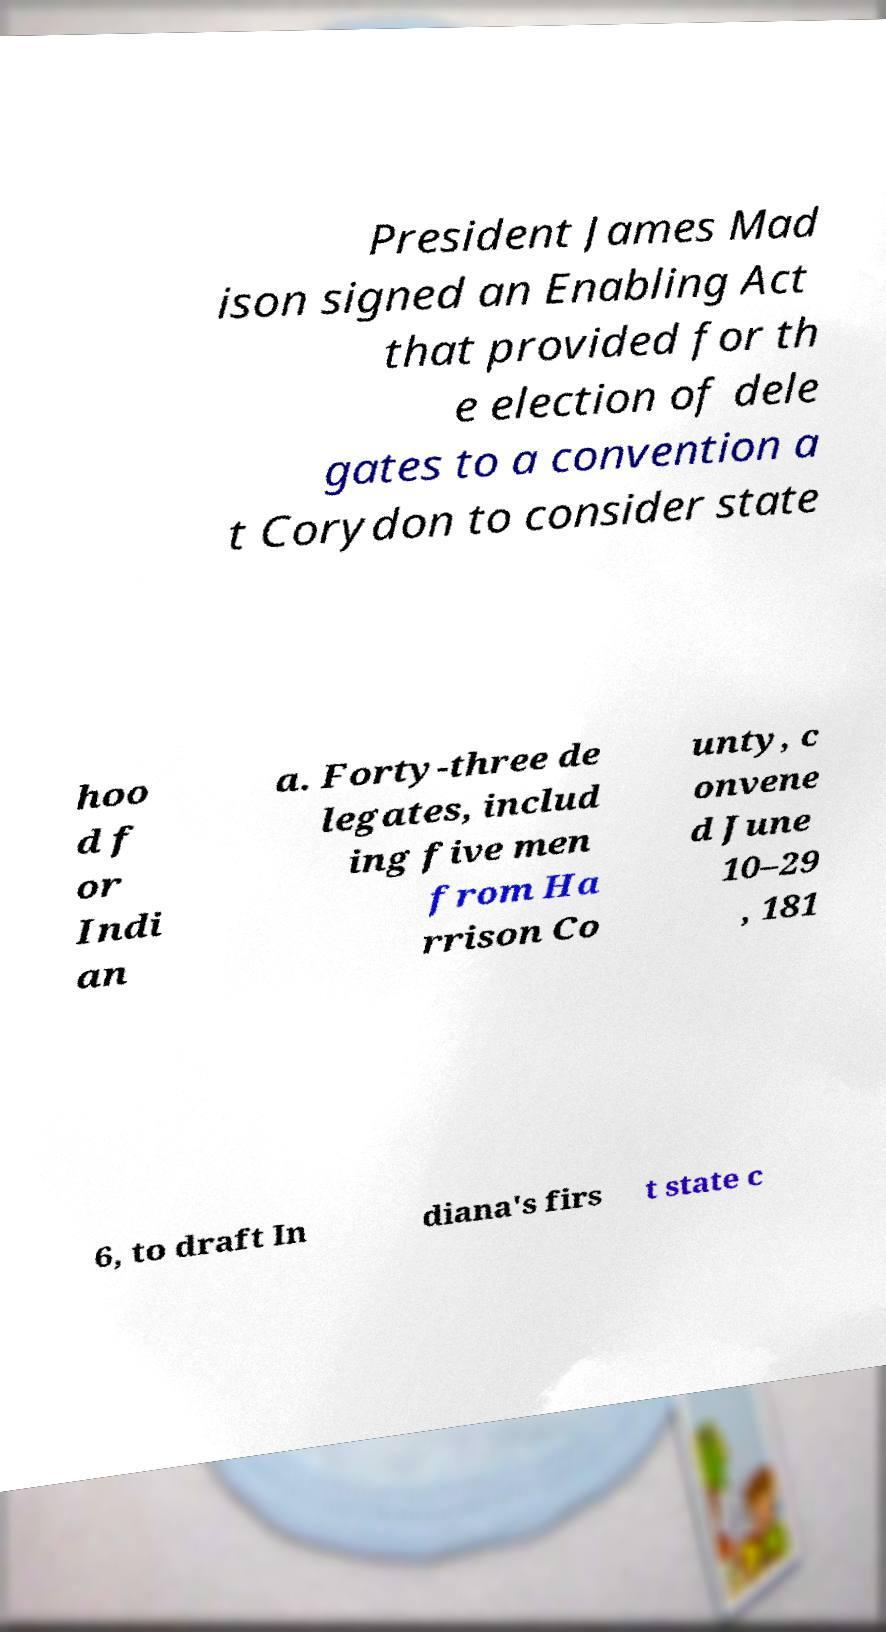For documentation purposes, I need the text within this image transcribed. Could you provide that? President James Mad ison signed an Enabling Act that provided for th e election of dele gates to a convention a t Corydon to consider state hoo d f or Indi an a. Forty-three de legates, includ ing five men from Ha rrison Co unty, c onvene d June 10–29 , 181 6, to draft In diana's firs t state c 